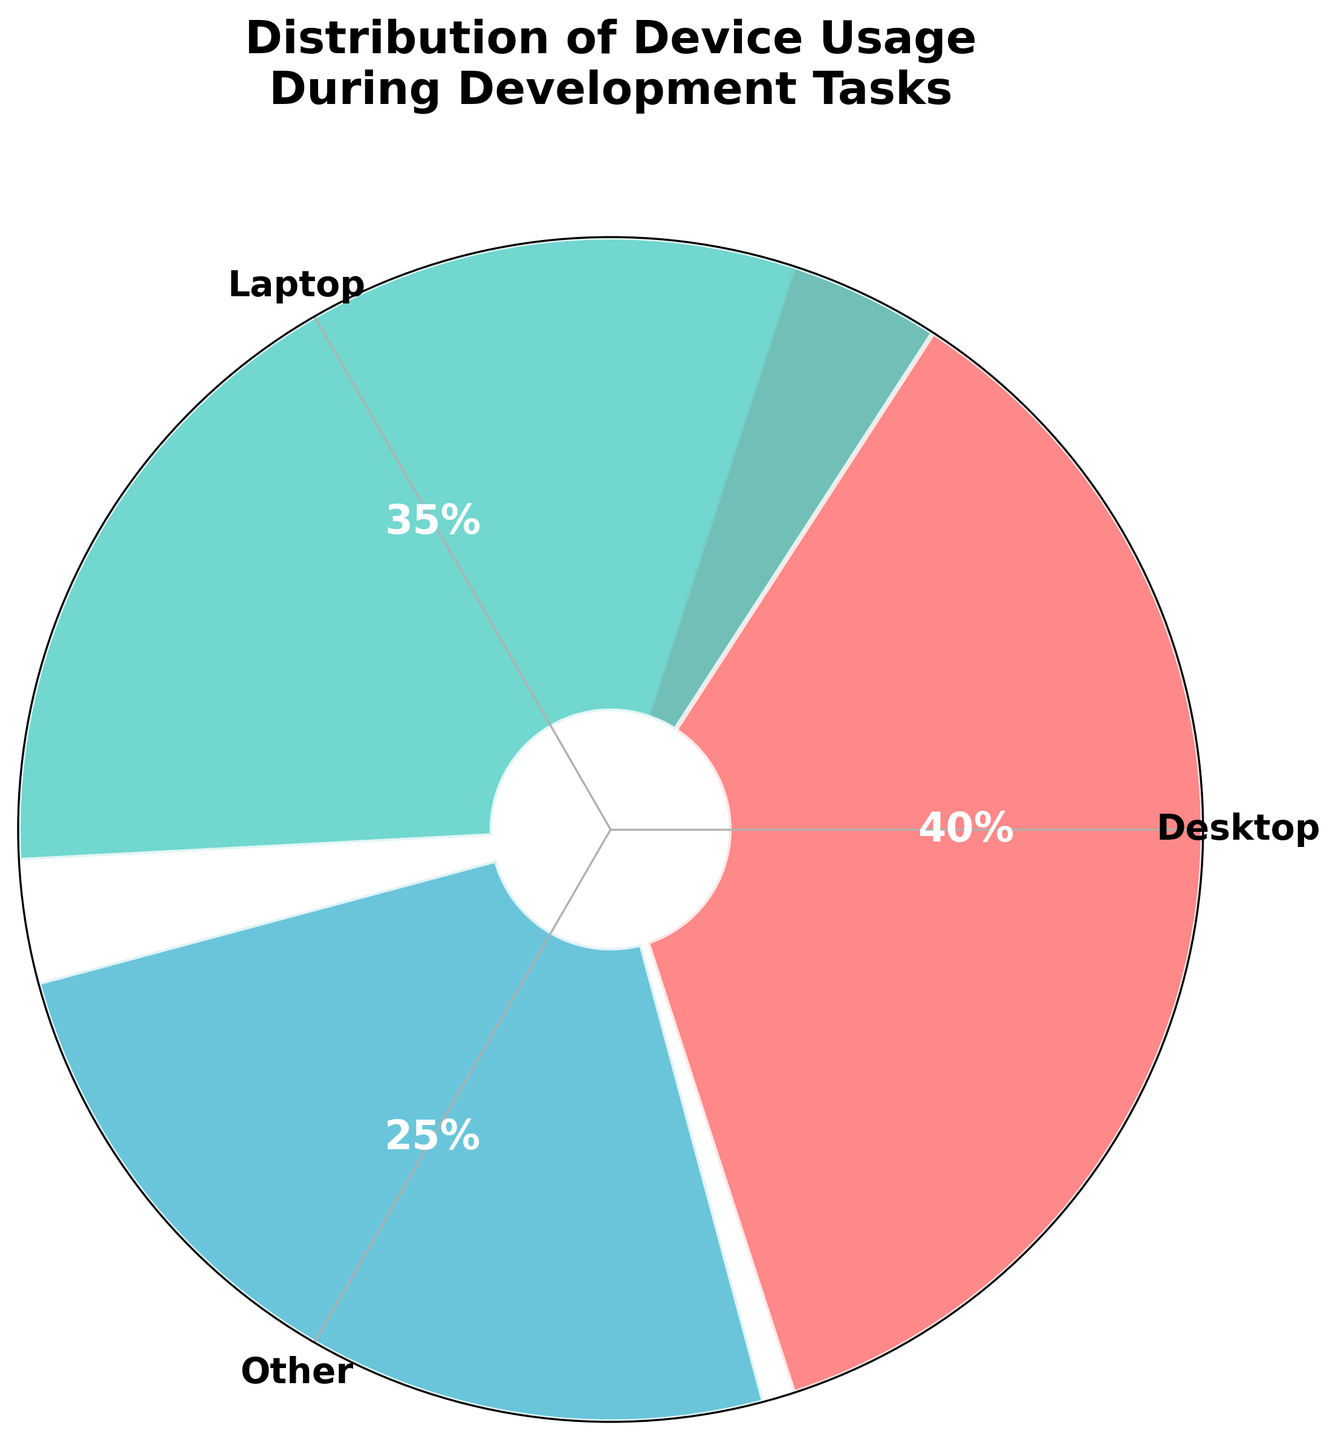What's the title of the figure? The title is clearly labeled at the top of the figure.
Answer: Distribution of Device Usage During Development Tasks What device has the highest usage percentage? By observing the heights and the percentage labels inside the figure, we can see that Desktop has the highest usage percentage.
Answer: Desktop What device category was combined into 'Other'? The explanation in the generated plot combines Tablet and Mobile into 'Other' category.
Answer: Tablet and Mobile What is the percentage usage of the 'Other' category? By looking at the figure, the 'Other' category has a percentage label representing the sum of Tablet and Mobile.
Answer: 25% What's the total percentage of Laptop and 'Other' combined? The figure shows Laptop usage at 35% and 'Other' at 25%. Adding them together results in 35% + 25% = 60%.
Answer: 60% Which color represents the usage percentage for Desktop? From the figure, Desktop is represented by the first color on the plot, which is red.
Answer: Red How many device categories are displayed in the plot? The plot displays three categories after combining some of the original data points. These are Desktop, Laptop, and 'Other'.
Answer: 3 Does the 'Other' category use more than 20% of devices? Referring to the figure, the 'Other' category usage is 25%, which is greater than 20%.
Answer: Yes What's the difference in usage percentage between Desktop and Laptop? The Desktop usage percentage is 40% and the Laptop usage percentage is 35%. The difference is 40% - 35% = 5%.
Answer: 5% Which device has the smallest usage percentage? Observing the figure shows that the smallest usage percentage is within the 'Other' category.
Answer: Other 